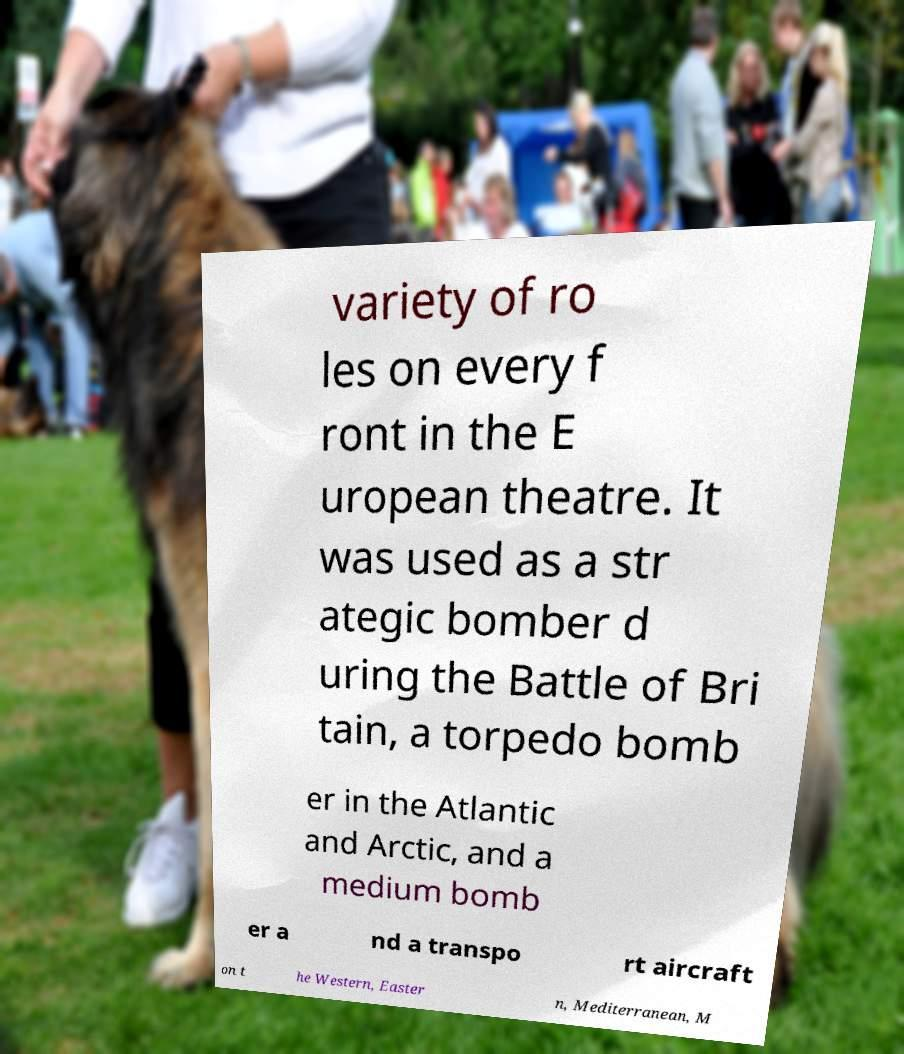Can you read and provide the text displayed in the image?This photo seems to have some interesting text. Can you extract and type it out for me? variety of ro les on every f ront in the E uropean theatre. It was used as a str ategic bomber d uring the Battle of Bri tain, a torpedo bomb er in the Atlantic and Arctic, and a medium bomb er a nd a transpo rt aircraft on t he Western, Easter n, Mediterranean, M 